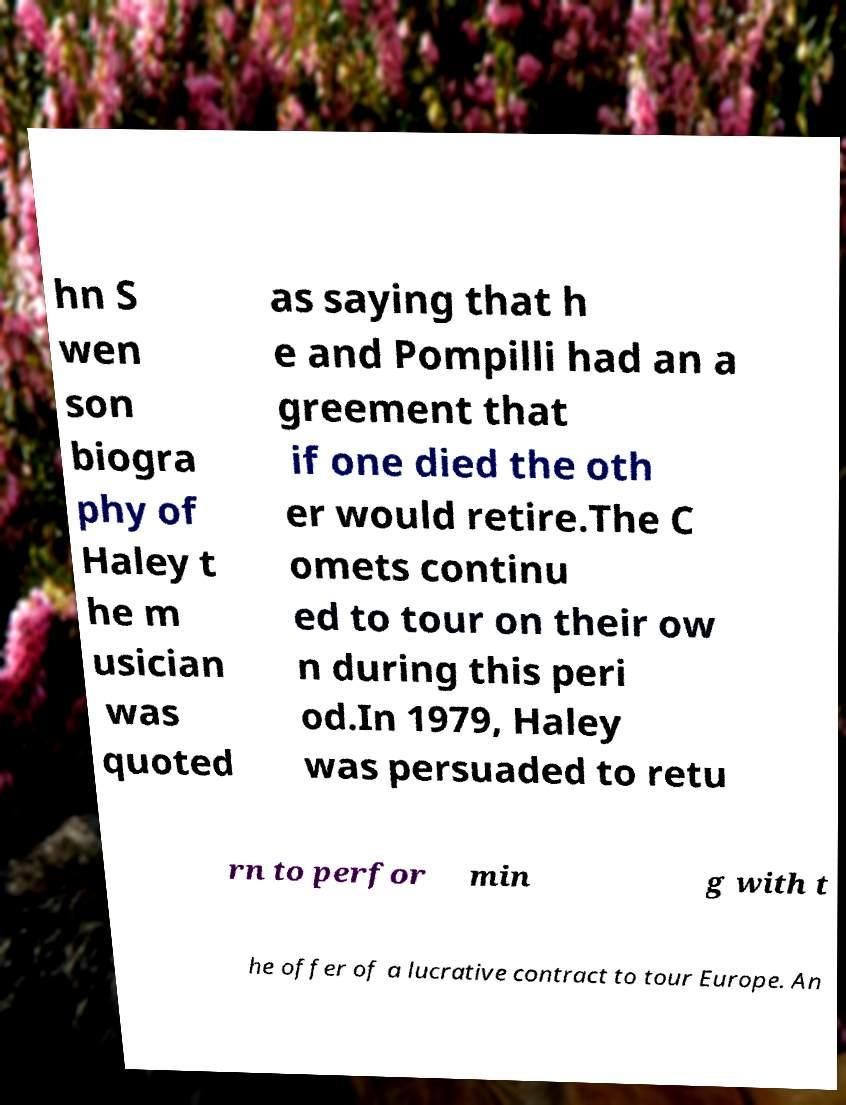For documentation purposes, I need the text within this image transcribed. Could you provide that? hn S wen son biogra phy of Haley t he m usician was quoted as saying that h e and Pompilli had an a greement that if one died the oth er would retire.The C omets continu ed to tour on their ow n during this peri od.In 1979, Haley was persuaded to retu rn to perfor min g with t he offer of a lucrative contract to tour Europe. An 